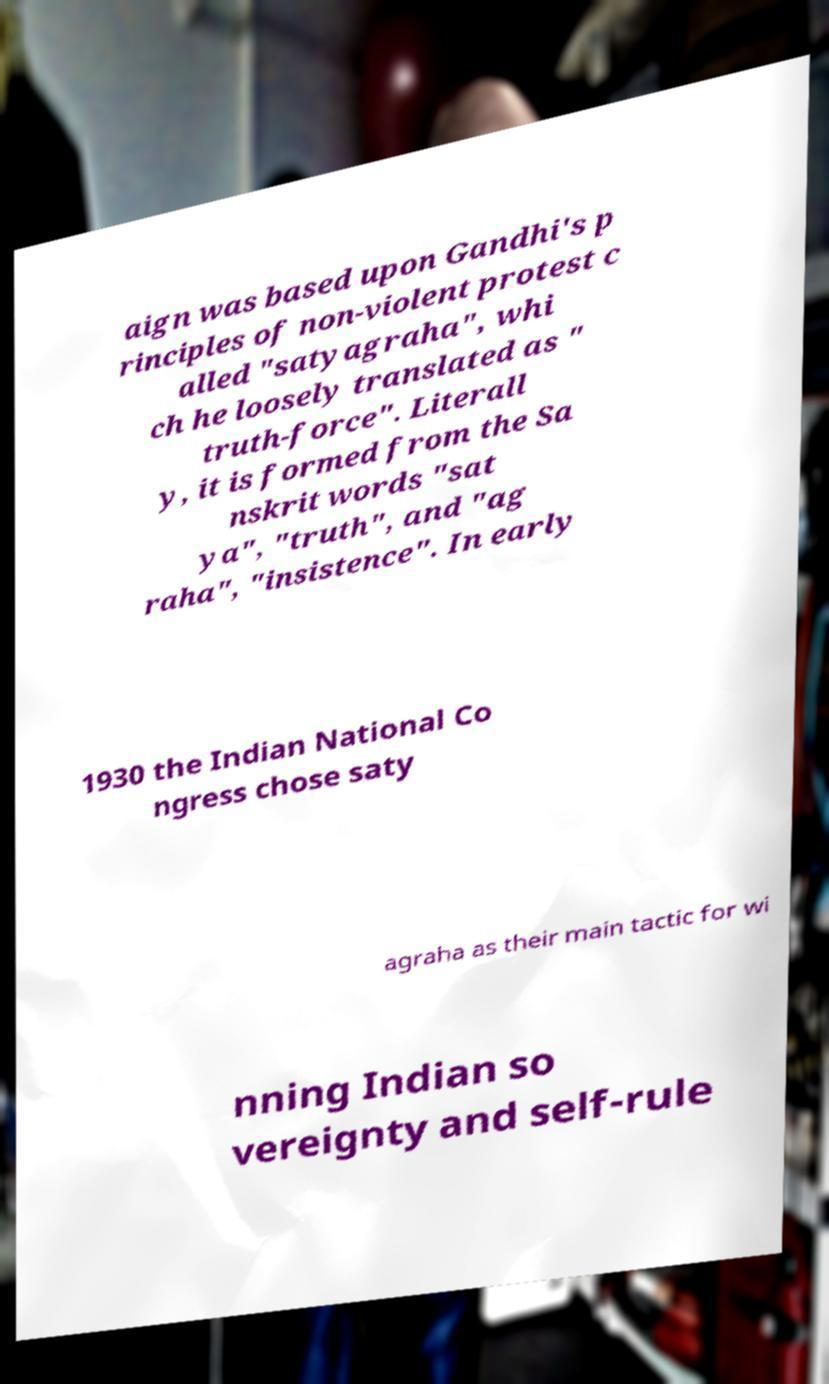Could you extract and type out the text from this image? aign was based upon Gandhi's p rinciples of non-violent protest c alled "satyagraha", whi ch he loosely translated as " truth-force". Literall y, it is formed from the Sa nskrit words "sat ya", "truth", and "ag raha", "insistence". In early 1930 the Indian National Co ngress chose saty agraha as their main tactic for wi nning Indian so vereignty and self-rule 